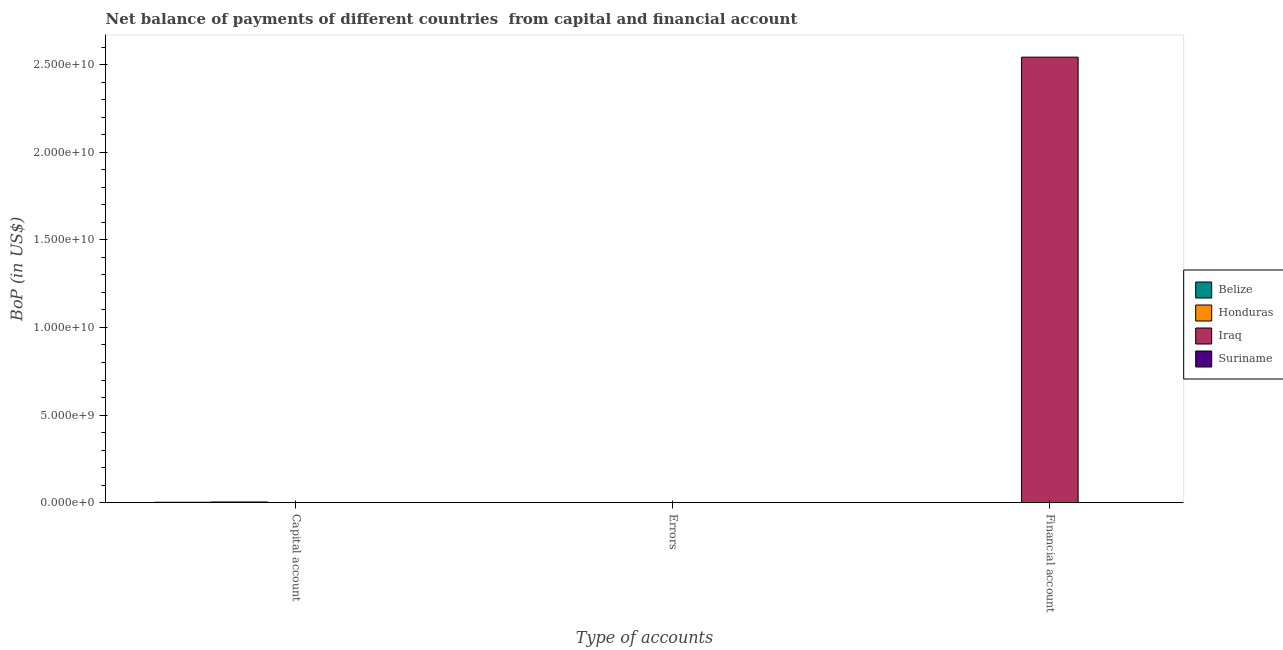How many different coloured bars are there?
Offer a terse response. 3. Are the number of bars on each tick of the X-axis equal?
Make the answer very short. No. How many bars are there on the 1st tick from the left?
Offer a terse response. 3. What is the label of the 1st group of bars from the left?
Offer a very short reply. Capital account. What is the amount of net capital account in Belize?
Make the answer very short. 2.25e+07. Across all countries, what is the maximum amount of financial account?
Your response must be concise. 2.54e+1. Across all countries, what is the minimum amount of financial account?
Give a very brief answer. 0. In which country was the amount of financial account maximum?
Keep it short and to the point. Iraq. What is the total amount of errors in the graph?
Make the answer very short. 0. What is the average amount of financial account per country?
Provide a short and direct response. 6.36e+09. What is the difference between the amount of financial account and amount of net capital account in Iraq?
Provide a short and direct response. 2.54e+1. In how many countries, is the amount of financial account greater than 19000000000 US$?
Your answer should be compact. 1. What is the difference between the highest and the second highest amount of net capital account?
Keep it short and to the point. 1.71e+07. What is the difference between the highest and the lowest amount of financial account?
Provide a succinct answer. 2.54e+1. In how many countries, is the amount of errors greater than the average amount of errors taken over all countries?
Offer a terse response. 0. Is it the case that in every country, the sum of the amount of net capital account and amount of errors is greater than the amount of financial account?
Provide a succinct answer. No. Are all the bars in the graph horizontal?
Ensure brevity in your answer.  No. How many countries are there in the graph?
Provide a succinct answer. 4. Does the graph contain any zero values?
Make the answer very short. Yes. Does the graph contain grids?
Ensure brevity in your answer.  No. How many legend labels are there?
Provide a short and direct response. 4. What is the title of the graph?
Your answer should be compact. Net balance of payments of different countries  from capital and financial account. What is the label or title of the X-axis?
Give a very brief answer. Type of accounts. What is the label or title of the Y-axis?
Offer a terse response. BoP (in US$). What is the BoP (in US$) in Belize in Capital account?
Provide a succinct answer. 2.25e+07. What is the BoP (in US$) of Honduras in Capital account?
Provide a short and direct response. 3.96e+07. What is the BoP (in US$) in Iraq in Capital account?
Your answer should be very brief. 7.00e+06. What is the BoP (in US$) in Belize in Errors?
Offer a very short reply. 0. What is the BoP (in US$) of Honduras in Errors?
Your answer should be very brief. 0. What is the BoP (in US$) in Iraq in Financial account?
Provide a succinct answer. 2.54e+1. Across all Type of accounts, what is the maximum BoP (in US$) of Belize?
Give a very brief answer. 2.25e+07. Across all Type of accounts, what is the maximum BoP (in US$) in Honduras?
Provide a short and direct response. 3.96e+07. Across all Type of accounts, what is the maximum BoP (in US$) of Iraq?
Offer a terse response. 2.54e+1. Across all Type of accounts, what is the minimum BoP (in US$) of Belize?
Provide a short and direct response. 0. Across all Type of accounts, what is the minimum BoP (in US$) in Honduras?
Make the answer very short. 0. Across all Type of accounts, what is the minimum BoP (in US$) in Iraq?
Keep it short and to the point. 0. What is the total BoP (in US$) in Belize in the graph?
Keep it short and to the point. 2.25e+07. What is the total BoP (in US$) of Honduras in the graph?
Make the answer very short. 3.96e+07. What is the total BoP (in US$) of Iraq in the graph?
Ensure brevity in your answer.  2.54e+1. What is the difference between the BoP (in US$) of Iraq in Capital account and that in Financial account?
Ensure brevity in your answer.  -2.54e+1. What is the difference between the BoP (in US$) of Belize in Capital account and the BoP (in US$) of Iraq in Financial account?
Make the answer very short. -2.54e+1. What is the difference between the BoP (in US$) in Honduras in Capital account and the BoP (in US$) in Iraq in Financial account?
Your response must be concise. -2.54e+1. What is the average BoP (in US$) of Belize per Type of accounts?
Provide a short and direct response. 7.50e+06. What is the average BoP (in US$) of Honduras per Type of accounts?
Your answer should be compact. 1.32e+07. What is the average BoP (in US$) of Iraq per Type of accounts?
Offer a very short reply. 8.48e+09. What is the difference between the BoP (in US$) of Belize and BoP (in US$) of Honduras in Capital account?
Ensure brevity in your answer.  -1.71e+07. What is the difference between the BoP (in US$) of Belize and BoP (in US$) of Iraq in Capital account?
Your answer should be very brief. 1.55e+07. What is the difference between the BoP (in US$) in Honduras and BoP (in US$) in Iraq in Capital account?
Make the answer very short. 3.26e+07. What is the difference between the highest and the lowest BoP (in US$) in Belize?
Provide a short and direct response. 2.25e+07. What is the difference between the highest and the lowest BoP (in US$) in Honduras?
Give a very brief answer. 3.96e+07. What is the difference between the highest and the lowest BoP (in US$) in Iraq?
Give a very brief answer. 2.54e+1. 